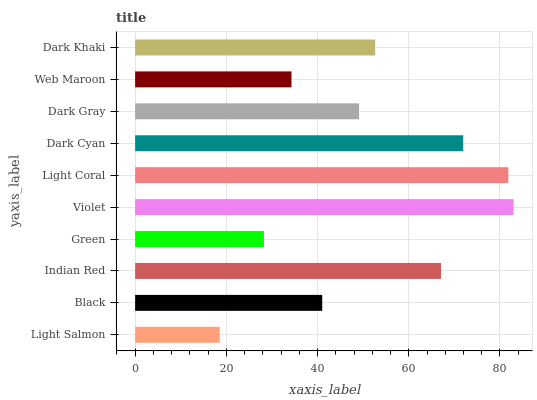Is Light Salmon the minimum?
Answer yes or no. Yes. Is Violet the maximum?
Answer yes or no. Yes. Is Black the minimum?
Answer yes or no. No. Is Black the maximum?
Answer yes or no. No. Is Black greater than Light Salmon?
Answer yes or no. Yes. Is Light Salmon less than Black?
Answer yes or no. Yes. Is Light Salmon greater than Black?
Answer yes or no. No. Is Black less than Light Salmon?
Answer yes or no. No. Is Dark Khaki the high median?
Answer yes or no. Yes. Is Dark Gray the low median?
Answer yes or no. Yes. Is Dark Cyan the high median?
Answer yes or no. No. Is Web Maroon the low median?
Answer yes or no. No. 